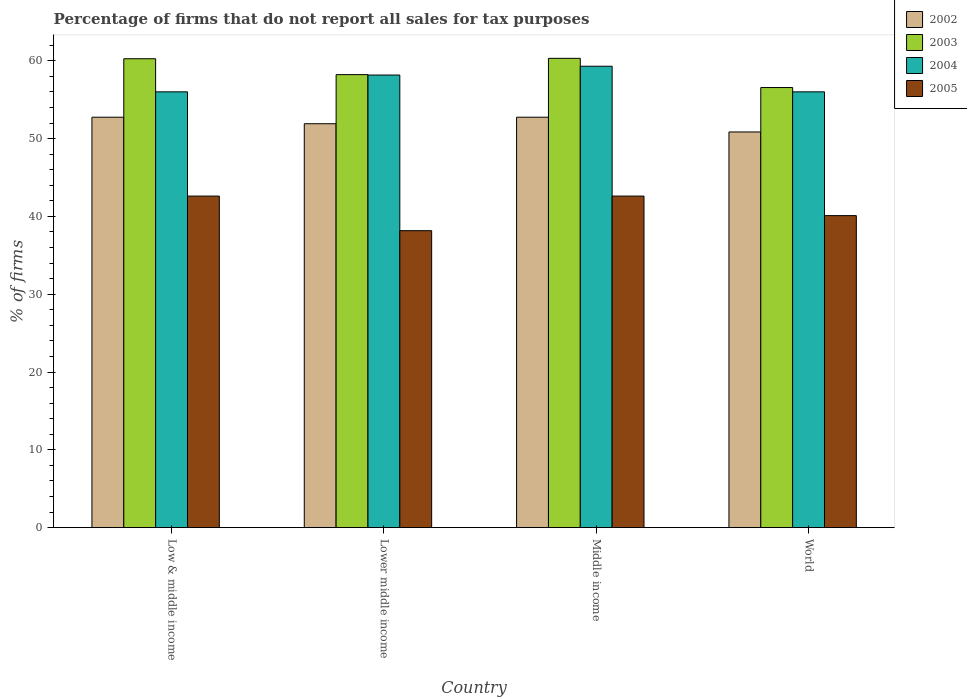How many different coloured bars are there?
Your answer should be very brief. 4. How many bars are there on the 3rd tick from the left?
Ensure brevity in your answer.  4. What is the percentage of firms that do not report all sales for tax purposes in 2002 in Low & middle income?
Offer a very short reply. 52.75. Across all countries, what is the maximum percentage of firms that do not report all sales for tax purposes in 2003?
Keep it short and to the point. 60.31. Across all countries, what is the minimum percentage of firms that do not report all sales for tax purposes in 2004?
Your answer should be very brief. 56.01. In which country was the percentage of firms that do not report all sales for tax purposes in 2003 maximum?
Provide a succinct answer. Middle income. In which country was the percentage of firms that do not report all sales for tax purposes in 2004 minimum?
Provide a short and direct response. Low & middle income. What is the total percentage of firms that do not report all sales for tax purposes in 2004 in the graph?
Give a very brief answer. 229.47. What is the difference between the percentage of firms that do not report all sales for tax purposes in 2002 in Lower middle income and that in Middle income?
Your answer should be very brief. -0.84. What is the difference between the percentage of firms that do not report all sales for tax purposes in 2005 in World and the percentage of firms that do not report all sales for tax purposes in 2003 in Middle income?
Ensure brevity in your answer.  -20.21. What is the average percentage of firms that do not report all sales for tax purposes in 2002 per country?
Your answer should be compact. 52.06. What is the difference between the percentage of firms that do not report all sales for tax purposes of/in 2003 and percentage of firms that do not report all sales for tax purposes of/in 2005 in World?
Offer a terse response. 16.46. In how many countries, is the percentage of firms that do not report all sales for tax purposes in 2003 greater than 42 %?
Your response must be concise. 4. What is the ratio of the percentage of firms that do not report all sales for tax purposes in 2003 in Low & middle income to that in Lower middle income?
Make the answer very short. 1.04. Is the difference between the percentage of firms that do not report all sales for tax purposes in 2003 in Low & middle income and World greater than the difference between the percentage of firms that do not report all sales for tax purposes in 2005 in Low & middle income and World?
Provide a succinct answer. Yes. What is the difference between the highest and the second highest percentage of firms that do not report all sales for tax purposes in 2003?
Ensure brevity in your answer.  -2.09. What is the difference between the highest and the lowest percentage of firms that do not report all sales for tax purposes in 2002?
Offer a very short reply. 1.89. In how many countries, is the percentage of firms that do not report all sales for tax purposes in 2002 greater than the average percentage of firms that do not report all sales for tax purposes in 2002 taken over all countries?
Offer a very short reply. 2. Does the graph contain grids?
Offer a terse response. No. How many legend labels are there?
Make the answer very short. 4. How are the legend labels stacked?
Your answer should be very brief. Vertical. What is the title of the graph?
Keep it short and to the point. Percentage of firms that do not report all sales for tax purposes. What is the label or title of the Y-axis?
Your response must be concise. % of firms. What is the % of firms in 2002 in Low & middle income?
Provide a short and direct response. 52.75. What is the % of firms of 2003 in Low & middle income?
Give a very brief answer. 60.26. What is the % of firms in 2004 in Low & middle income?
Give a very brief answer. 56.01. What is the % of firms in 2005 in Low & middle income?
Your answer should be very brief. 42.61. What is the % of firms of 2002 in Lower middle income?
Keep it short and to the point. 51.91. What is the % of firms in 2003 in Lower middle income?
Make the answer very short. 58.22. What is the % of firms in 2004 in Lower middle income?
Provide a short and direct response. 58.16. What is the % of firms of 2005 in Lower middle income?
Your answer should be very brief. 38.16. What is the % of firms in 2002 in Middle income?
Give a very brief answer. 52.75. What is the % of firms in 2003 in Middle income?
Make the answer very short. 60.31. What is the % of firms in 2004 in Middle income?
Offer a terse response. 59.3. What is the % of firms of 2005 in Middle income?
Keep it short and to the point. 42.61. What is the % of firms in 2002 in World?
Offer a terse response. 50.85. What is the % of firms of 2003 in World?
Offer a very short reply. 56.56. What is the % of firms in 2004 in World?
Ensure brevity in your answer.  56.01. What is the % of firms in 2005 in World?
Offer a very short reply. 40.1. Across all countries, what is the maximum % of firms of 2002?
Give a very brief answer. 52.75. Across all countries, what is the maximum % of firms in 2003?
Offer a very short reply. 60.31. Across all countries, what is the maximum % of firms in 2004?
Give a very brief answer. 59.3. Across all countries, what is the maximum % of firms in 2005?
Your answer should be very brief. 42.61. Across all countries, what is the minimum % of firms of 2002?
Your answer should be very brief. 50.85. Across all countries, what is the minimum % of firms in 2003?
Offer a terse response. 56.56. Across all countries, what is the minimum % of firms of 2004?
Your answer should be very brief. 56.01. Across all countries, what is the minimum % of firms in 2005?
Keep it short and to the point. 38.16. What is the total % of firms in 2002 in the graph?
Make the answer very short. 208.25. What is the total % of firms of 2003 in the graph?
Your answer should be very brief. 235.35. What is the total % of firms in 2004 in the graph?
Give a very brief answer. 229.47. What is the total % of firms in 2005 in the graph?
Ensure brevity in your answer.  163.48. What is the difference between the % of firms in 2002 in Low & middle income and that in Lower middle income?
Offer a terse response. 0.84. What is the difference between the % of firms of 2003 in Low & middle income and that in Lower middle income?
Give a very brief answer. 2.04. What is the difference between the % of firms in 2004 in Low & middle income and that in Lower middle income?
Your answer should be compact. -2.16. What is the difference between the % of firms in 2005 in Low & middle income and that in Lower middle income?
Provide a succinct answer. 4.45. What is the difference between the % of firms in 2003 in Low & middle income and that in Middle income?
Give a very brief answer. -0.05. What is the difference between the % of firms of 2004 in Low & middle income and that in Middle income?
Your response must be concise. -3.29. What is the difference between the % of firms in 2002 in Low & middle income and that in World?
Your answer should be very brief. 1.89. What is the difference between the % of firms of 2003 in Low & middle income and that in World?
Keep it short and to the point. 3.7. What is the difference between the % of firms in 2004 in Low & middle income and that in World?
Your answer should be compact. 0. What is the difference between the % of firms in 2005 in Low & middle income and that in World?
Provide a short and direct response. 2.51. What is the difference between the % of firms of 2002 in Lower middle income and that in Middle income?
Your answer should be very brief. -0.84. What is the difference between the % of firms in 2003 in Lower middle income and that in Middle income?
Ensure brevity in your answer.  -2.09. What is the difference between the % of firms of 2004 in Lower middle income and that in Middle income?
Offer a very short reply. -1.13. What is the difference between the % of firms of 2005 in Lower middle income and that in Middle income?
Your answer should be very brief. -4.45. What is the difference between the % of firms of 2002 in Lower middle income and that in World?
Your response must be concise. 1.06. What is the difference between the % of firms in 2003 in Lower middle income and that in World?
Give a very brief answer. 1.66. What is the difference between the % of firms in 2004 in Lower middle income and that in World?
Provide a short and direct response. 2.16. What is the difference between the % of firms in 2005 in Lower middle income and that in World?
Offer a terse response. -1.94. What is the difference between the % of firms in 2002 in Middle income and that in World?
Give a very brief answer. 1.89. What is the difference between the % of firms in 2003 in Middle income and that in World?
Provide a succinct answer. 3.75. What is the difference between the % of firms of 2004 in Middle income and that in World?
Give a very brief answer. 3.29. What is the difference between the % of firms of 2005 in Middle income and that in World?
Offer a terse response. 2.51. What is the difference between the % of firms of 2002 in Low & middle income and the % of firms of 2003 in Lower middle income?
Offer a very short reply. -5.47. What is the difference between the % of firms in 2002 in Low & middle income and the % of firms in 2004 in Lower middle income?
Provide a short and direct response. -5.42. What is the difference between the % of firms of 2002 in Low & middle income and the % of firms of 2005 in Lower middle income?
Provide a short and direct response. 14.58. What is the difference between the % of firms of 2003 in Low & middle income and the % of firms of 2004 in Lower middle income?
Your answer should be compact. 2.1. What is the difference between the % of firms of 2003 in Low & middle income and the % of firms of 2005 in Lower middle income?
Offer a very short reply. 22.1. What is the difference between the % of firms of 2004 in Low & middle income and the % of firms of 2005 in Lower middle income?
Your answer should be very brief. 17.84. What is the difference between the % of firms in 2002 in Low & middle income and the % of firms in 2003 in Middle income?
Give a very brief answer. -7.57. What is the difference between the % of firms of 2002 in Low & middle income and the % of firms of 2004 in Middle income?
Ensure brevity in your answer.  -6.55. What is the difference between the % of firms of 2002 in Low & middle income and the % of firms of 2005 in Middle income?
Offer a very short reply. 10.13. What is the difference between the % of firms in 2003 in Low & middle income and the % of firms in 2004 in Middle income?
Your answer should be compact. 0.96. What is the difference between the % of firms in 2003 in Low & middle income and the % of firms in 2005 in Middle income?
Your answer should be compact. 17.65. What is the difference between the % of firms in 2004 in Low & middle income and the % of firms in 2005 in Middle income?
Offer a terse response. 13.39. What is the difference between the % of firms in 2002 in Low & middle income and the % of firms in 2003 in World?
Provide a succinct answer. -3.81. What is the difference between the % of firms in 2002 in Low & middle income and the % of firms in 2004 in World?
Your answer should be very brief. -3.26. What is the difference between the % of firms in 2002 in Low & middle income and the % of firms in 2005 in World?
Your answer should be compact. 12.65. What is the difference between the % of firms of 2003 in Low & middle income and the % of firms of 2004 in World?
Your answer should be compact. 4.25. What is the difference between the % of firms of 2003 in Low & middle income and the % of firms of 2005 in World?
Your answer should be compact. 20.16. What is the difference between the % of firms of 2004 in Low & middle income and the % of firms of 2005 in World?
Your response must be concise. 15.91. What is the difference between the % of firms in 2002 in Lower middle income and the % of firms in 2003 in Middle income?
Give a very brief answer. -8.4. What is the difference between the % of firms in 2002 in Lower middle income and the % of firms in 2004 in Middle income?
Your answer should be very brief. -7.39. What is the difference between the % of firms in 2002 in Lower middle income and the % of firms in 2005 in Middle income?
Your answer should be very brief. 9.3. What is the difference between the % of firms of 2003 in Lower middle income and the % of firms of 2004 in Middle income?
Make the answer very short. -1.08. What is the difference between the % of firms of 2003 in Lower middle income and the % of firms of 2005 in Middle income?
Offer a terse response. 15.61. What is the difference between the % of firms of 2004 in Lower middle income and the % of firms of 2005 in Middle income?
Ensure brevity in your answer.  15.55. What is the difference between the % of firms of 2002 in Lower middle income and the % of firms of 2003 in World?
Your response must be concise. -4.65. What is the difference between the % of firms of 2002 in Lower middle income and the % of firms of 2004 in World?
Your response must be concise. -4.1. What is the difference between the % of firms of 2002 in Lower middle income and the % of firms of 2005 in World?
Your answer should be compact. 11.81. What is the difference between the % of firms of 2003 in Lower middle income and the % of firms of 2004 in World?
Offer a terse response. 2.21. What is the difference between the % of firms in 2003 in Lower middle income and the % of firms in 2005 in World?
Your answer should be very brief. 18.12. What is the difference between the % of firms in 2004 in Lower middle income and the % of firms in 2005 in World?
Provide a short and direct response. 18.07. What is the difference between the % of firms of 2002 in Middle income and the % of firms of 2003 in World?
Your response must be concise. -3.81. What is the difference between the % of firms in 2002 in Middle income and the % of firms in 2004 in World?
Your response must be concise. -3.26. What is the difference between the % of firms in 2002 in Middle income and the % of firms in 2005 in World?
Make the answer very short. 12.65. What is the difference between the % of firms in 2003 in Middle income and the % of firms in 2004 in World?
Provide a short and direct response. 4.31. What is the difference between the % of firms in 2003 in Middle income and the % of firms in 2005 in World?
Provide a succinct answer. 20.21. What is the difference between the % of firms in 2004 in Middle income and the % of firms in 2005 in World?
Offer a terse response. 19.2. What is the average % of firms of 2002 per country?
Offer a terse response. 52.06. What is the average % of firms in 2003 per country?
Give a very brief answer. 58.84. What is the average % of firms of 2004 per country?
Provide a short and direct response. 57.37. What is the average % of firms in 2005 per country?
Offer a terse response. 40.87. What is the difference between the % of firms in 2002 and % of firms in 2003 in Low & middle income?
Make the answer very short. -7.51. What is the difference between the % of firms in 2002 and % of firms in 2004 in Low & middle income?
Offer a terse response. -3.26. What is the difference between the % of firms of 2002 and % of firms of 2005 in Low & middle income?
Provide a succinct answer. 10.13. What is the difference between the % of firms in 2003 and % of firms in 2004 in Low & middle income?
Your answer should be very brief. 4.25. What is the difference between the % of firms in 2003 and % of firms in 2005 in Low & middle income?
Keep it short and to the point. 17.65. What is the difference between the % of firms of 2004 and % of firms of 2005 in Low & middle income?
Keep it short and to the point. 13.39. What is the difference between the % of firms of 2002 and % of firms of 2003 in Lower middle income?
Offer a very short reply. -6.31. What is the difference between the % of firms in 2002 and % of firms in 2004 in Lower middle income?
Offer a terse response. -6.26. What is the difference between the % of firms of 2002 and % of firms of 2005 in Lower middle income?
Ensure brevity in your answer.  13.75. What is the difference between the % of firms in 2003 and % of firms in 2004 in Lower middle income?
Keep it short and to the point. 0.05. What is the difference between the % of firms in 2003 and % of firms in 2005 in Lower middle income?
Offer a very short reply. 20.06. What is the difference between the % of firms in 2004 and % of firms in 2005 in Lower middle income?
Your answer should be compact. 20. What is the difference between the % of firms of 2002 and % of firms of 2003 in Middle income?
Offer a very short reply. -7.57. What is the difference between the % of firms of 2002 and % of firms of 2004 in Middle income?
Keep it short and to the point. -6.55. What is the difference between the % of firms in 2002 and % of firms in 2005 in Middle income?
Make the answer very short. 10.13. What is the difference between the % of firms of 2003 and % of firms of 2004 in Middle income?
Provide a succinct answer. 1.02. What is the difference between the % of firms of 2003 and % of firms of 2005 in Middle income?
Your answer should be compact. 17.7. What is the difference between the % of firms in 2004 and % of firms in 2005 in Middle income?
Provide a short and direct response. 16.69. What is the difference between the % of firms in 2002 and % of firms in 2003 in World?
Ensure brevity in your answer.  -5.71. What is the difference between the % of firms of 2002 and % of firms of 2004 in World?
Ensure brevity in your answer.  -5.15. What is the difference between the % of firms in 2002 and % of firms in 2005 in World?
Make the answer very short. 10.75. What is the difference between the % of firms of 2003 and % of firms of 2004 in World?
Ensure brevity in your answer.  0.56. What is the difference between the % of firms in 2003 and % of firms in 2005 in World?
Offer a terse response. 16.46. What is the difference between the % of firms of 2004 and % of firms of 2005 in World?
Offer a very short reply. 15.91. What is the ratio of the % of firms in 2002 in Low & middle income to that in Lower middle income?
Your answer should be compact. 1.02. What is the ratio of the % of firms of 2003 in Low & middle income to that in Lower middle income?
Provide a short and direct response. 1.04. What is the ratio of the % of firms in 2004 in Low & middle income to that in Lower middle income?
Make the answer very short. 0.96. What is the ratio of the % of firms of 2005 in Low & middle income to that in Lower middle income?
Offer a terse response. 1.12. What is the ratio of the % of firms of 2002 in Low & middle income to that in Middle income?
Provide a short and direct response. 1. What is the ratio of the % of firms of 2003 in Low & middle income to that in Middle income?
Make the answer very short. 1. What is the ratio of the % of firms of 2004 in Low & middle income to that in Middle income?
Your answer should be very brief. 0.94. What is the ratio of the % of firms of 2002 in Low & middle income to that in World?
Your answer should be compact. 1.04. What is the ratio of the % of firms in 2003 in Low & middle income to that in World?
Your answer should be compact. 1.07. What is the ratio of the % of firms in 2004 in Low & middle income to that in World?
Your response must be concise. 1. What is the ratio of the % of firms of 2005 in Low & middle income to that in World?
Your answer should be very brief. 1.06. What is the ratio of the % of firms of 2002 in Lower middle income to that in Middle income?
Provide a succinct answer. 0.98. What is the ratio of the % of firms of 2003 in Lower middle income to that in Middle income?
Give a very brief answer. 0.97. What is the ratio of the % of firms in 2004 in Lower middle income to that in Middle income?
Provide a succinct answer. 0.98. What is the ratio of the % of firms of 2005 in Lower middle income to that in Middle income?
Keep it short and to the point. 0.9. What is the ratio of the % of firms of 2002 in Lower middle income to that in World?
Give a very brief answer. 1.02. What is the ratio of the % of firms of 2003 in Lower middle income to that in World?
Your answer should be very brief. 1.03. What is the ratio of the % of firms of 2004 in Lower middle income to that in World?
Provide a short and direct response. 1.04. What is the ratio of the % of firms of 2005 in Lower middle income to that in World?
Offer a terse response. 0.95. What is the ratio of the % of firms in 2002 in Middle income to that in World?
Your response must be concise. 1.04. What is the ratio of the % of firms in 2003 in Middle income to that in World?
Your response must be concise. 1.07. What is the ratio of the % of firms in 2004 in Middle income to that in World?
Give a very brief answer. 1.06. What is the ratio of the % of firms in 2005 in Middle income to that in World?
Ensure brevity in your answer.  1.06. What is the difference between the highest and the second highest % of firms of 2003?
Make the answer very short. 0.05. What is the difference between the highest and the second highest % of firms of 2004?
Ensure brevity in your answer.  1.13. What is the difference between the highest and the second highest % of firms in 2005?
Your response must be concise. 0. What is the difference between the highest and the lowest % of firms of 2002?
Provide a succinct answer. 1.89. What is the difference between the highest and the lowest % of firms of 2003?
Keep it short and to the point. 3.75. What is the difference between the highest and the lowest % of firms in 2004?
Keep it short and to the point. 3.29. What is the difference between the highest and the lowest % of firms of 2005?
Ensure brevity in your answer.  4.45. 